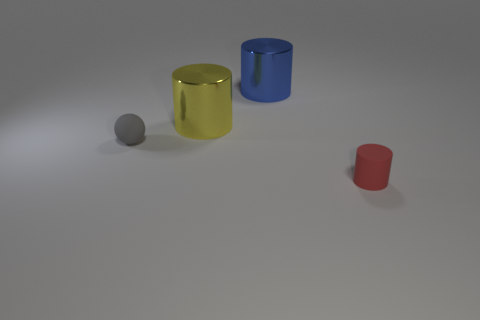Add 3 cyan cylinders. How many objects exist? 7 Subtract all cylinders. How many objects are left? 1 Subtract all gray things. Subtract all yellow metallic objects. How many objects are left? 2 Add 4 yellow metal cylinders. How many yellow metal cylinders are left? 5 Add 1 brown matte objects. How many brown matte objects exist? 1 Subtract 0 cyan cylinders. How many objects are left? 4 